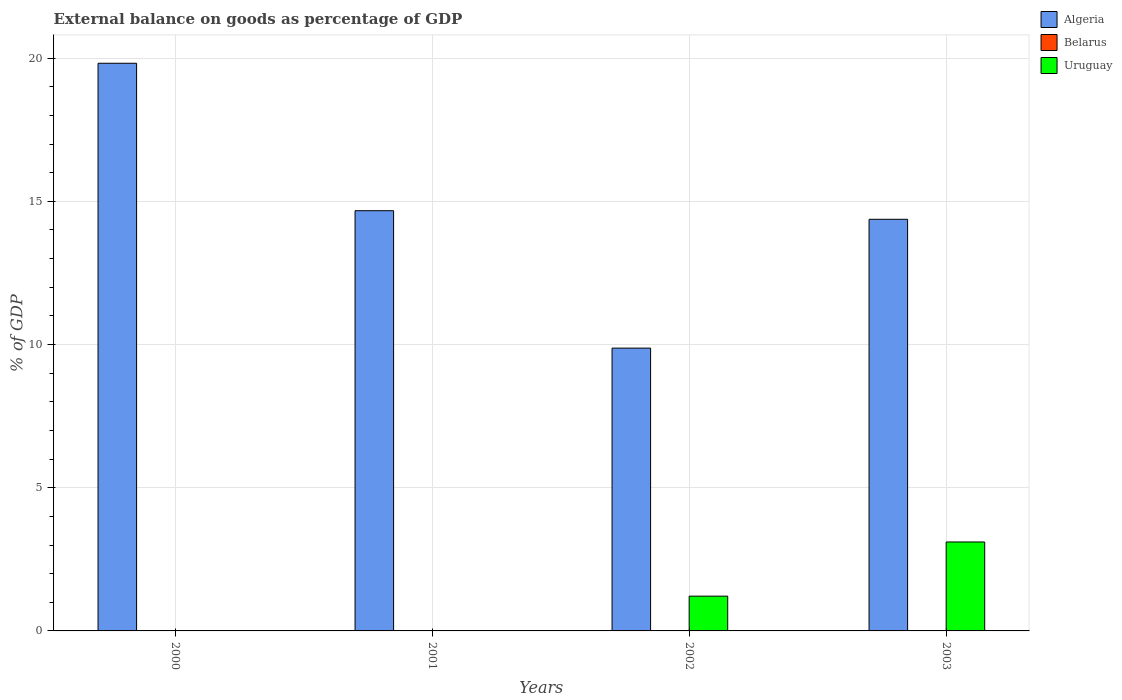Are the number of bars per tick equal to the number of legend labels?
Offer a very short reply. No. How many bars are there on the 2nd tick from the left?
Give a very brief answer. 1. Across all years, what is the maximum external balance on goods as percentage of GDP in Uruguay?
Keep it short and to the point. 3.11. In which year was the external balance on goods as percentage of GDP in Algeria maximum?
Offer a very short reply. 2000. What is the total external balance on goods as percentage of GDP in Algeria in the graph?
Provide a short and direct response. 58.74. What is the difference between the external balance on goods as percentage of GDP in Algeria in 2001 and that in 2003?
Provide a short and direct response. 0.3. What is the difference between the external balance on goods as percentage of GDP in Uruguay in 2000 and the external balance on goods as percentage of GDP in Algeria in 2002?
Provide a succinct answer. -9.87. What is the average external balance on goods as percentage of GDP in Uruguay per year?
Provide a short and direct response. 1.08. In the year 2002, what is the difference between the external balance on goods as percentage of GDP in Algeria and external balance on goods as percentage of GDP in Uruguay?
Provide a short and direct response. 8.66. In how many years, is the external balance on goods as percentage of GDP in Belarus greater than 4 %?
Give a very brief answer. 0. What is the ratio of the external balance on goods as percentage of GDP in Algeria in 2001 to that in 2002?
Your response must be concise. 1.49. Is the external balance on goods as percentage of GDP in Algeria in 2000 less than that in 2003?
Your answer should be compact. No. What is the difference between the highest and the second highest external balance on goods as percentage of GDP in Algeria?
Your answer should be compact. 5.15. What is the difference between the highest and the lowest external balance on goods as percentage of GDP in Algeria?
Your answer should be compact. 9.95. In how many years, is the external balance on goods as percentage of GDP in Belarus greater than the average external balance on goods as percentage of GDP in Belarus taken over all years?
Provide a succinct answer. 0. Is the sum of the external balance on goods as percentage of GDP in Algeria in 2002 and 2003 greater than the maximum external balance on goods as percentage of GDP in Uruguay across all years?
Your response must be concise. Yes. Is it the case that in every year, the sum of the external balance on goods as percentage of GDP in Algeria and external balance on goods as percentage of GDP in Belarus is greater than the external balance on goods as percentage of GDP in Uruguay?
Your response must be concise. Yes. What is the difference between two consecutive major ticks on the Y-axis?
Make the answer very short. 5. Are the values on the major ticks of Y-axis written in scientific E-notation?
Offer a very short reply. No. Where does the legend appear in the graph?
Your response must be concise. Top right. What is the title of the graph?
Your answer should be very brief. External balance on goods as percentage of GDP. Does "Middle East & North Africa (all income levels)" appear as one of the legend labels in the graph?
Your response must be concise. No. What is the label or title of the Y-axis?
Provide a succinct answer. % of GDP. What is the % of GDP in Algeria in 2000?
Make the answer very short. 19.82. What is the % of GDP of Belarus in 2000?
Ensure brevity in your answer.  0. What is the % of GDP in Algeria in 2001?
Your answer should be very brief. 14.67. What is the % of GDP of Belarus in 2001?
Your answer should be compact. 0. What is the % of GDP in Uruguay in 2001?
Offer a terse response. 0. What is the % of GDP of Algeria in 2002?
Give a very brief answer. 9.87. What is the % of GDP of Belarus in 2002?
Keep it short and to the point. 0. What is the % of GDP in Uruguay in 2002?
Offer a terse response. 1.21. What is the % of GDP in Algeria in 2003?
Provide a succinct answer. 14.37. What is the % of GDP of Uruguay in 2003?
Keep it short and to the point. 3.11. Across all years, what is the maximum % of GDP in Algeria?
Ensure brevity in your answer.  19.82. Across all years, what is the maximum % of GDP in Uruguay?
Provide a short and direct response. 3.11. Across all years, what is the minimum % of GDP in Algeria?
Keep it short and to the point. 9.87. What is the total % of GDP of Algeria in the graph?
Your answer should be very brief. 58.74. What is the total % of GDP of Uruguay in the graph?
Provide a succinct answer. 4.32. What is the difference between the % of GDP of Algeria in 2000 and that in 2001?
Keep it short and to the point. 5.15. What is the difference between the % of GDP in Algeria in 2000 and that in 2002?
Provide a succinct answer. 9.95. What is the difference between the % of GDP of Algeria in 2000 and that in 2003?
Provide a short and direct response. 5.45. What is the difference between the % of GDP of Algeria in 2001 and that in 2002?
Make the answer very short. 4.8. What is the difference between the % of GDP in Algeria in 2001 and that in 2003?
Give a very brief answer. 0.3. What is the difference between the % of GDP in Algeria in 2002 and that in 2003?
Keep it short and to the point. -4.5. What is the difference between the % of GDP of Uruguay in 2002 and that in 2003?
Your response must be concise. -1.89. What is the difference between the % of GDP in Algeria in 2000 and the % of GDP in Uruguay in 2002?
Provide a short and direct response. 18.61. What is the difference between the % of GDP of Algeria in 2000 and the % of GDP of Uruguay in 2003?
Provide a succinct answer. 16.72. What is the difference between the % of GDP of Algeria in 2001 and the % of GDP of Uruguay in 2002?
Make the answer very short. 13.46. What is the difference between the % of GDP of Algeria in 2001 and the % of GDP of Uruguay in 2003?
Your response must be concise. 11.57. What is the difference between the % of GDP of Algeria in 2002 and the % of GDP of Uruguay in 2003?
Provide a short and direct response. 6.77. What is the average % of GDP in Algeria per year?
Provide a succinct answer. 14.69. In the year 2002, what is the difference between the % of GDP in Algeria and % of GDP in Uruguay?
Offer a terse response. 8.66. In the year 2003, what is the difference between the % of GDP in Algeria and % of GDP in Uruguay?
Make the answer very short. 11.27. What is the ratio of the % of GDP of Algeria in 2000 to that in 2001?
Ensure brevity in your answer.  1.35. What is the ratio of the % of GDP of Algeria in 2000 to that in 2002?
Provide a succinct answer. 2.01. What is the ratio of the % of GDP in Algeria in 2000 to that in 2003?
Provide a short and direct response. 1.38. What is the ratio of the % of GDP in Algeria in 2001 to that in 2002?
Provide a succinct answer. 1.49. What is the ratio of the % of GDP of Algeria in 2001 to that in 2003?
Make the answer very short. 1.02. What is the ratio of the % of GDP of Algeria in 2002 to that in 2003?
Your answer should be compact. 0.69. What is the ratio of the % of GDP of Uruguay in 2002 to that in 2003?
Your answer should be very brief. 0.39. What is the difference between the highest and the second highest % of GDP of Algeria?
Your answer should be compact. 5.15. What is the difference between the highest and the lowest % of GDP of Algeria?
Ensure brevity in your answer.  9.95. What is the difference between the highest and the lowest % of GDP in Uruguay?
Your answer should be very brief. 3.11. 